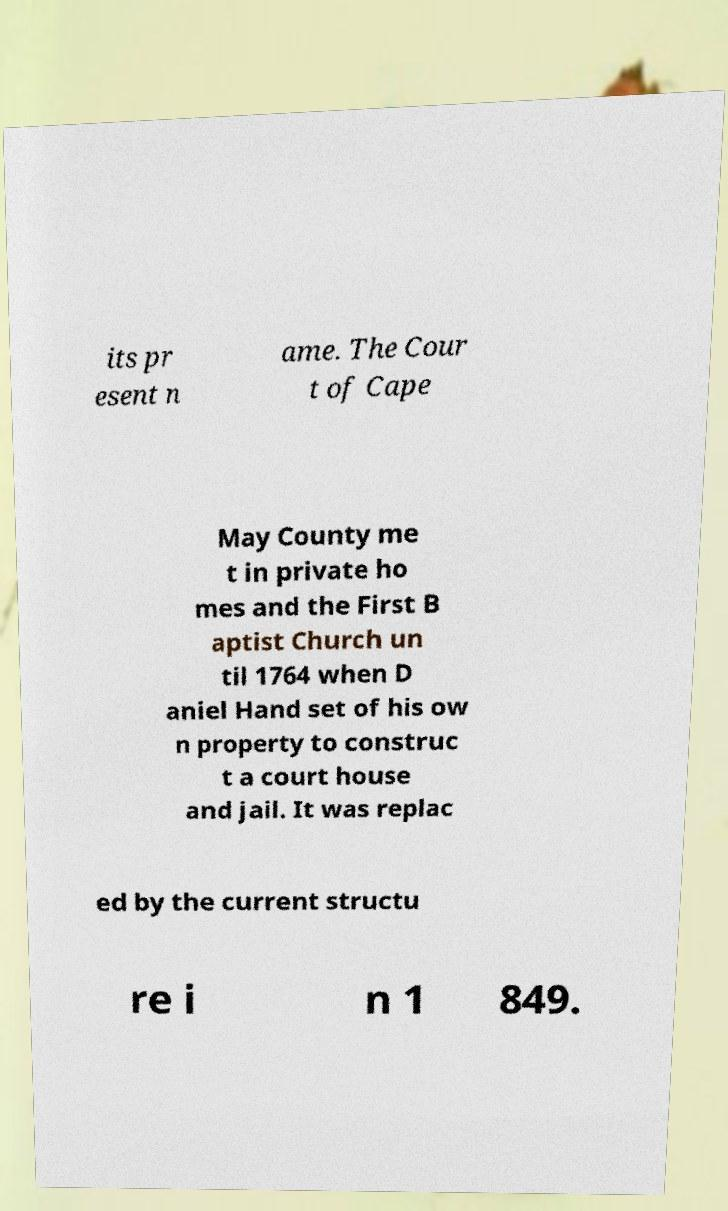For documentation purposes, I need the text within this image transcribed. Could you provide that? its pr esent n ame. The Cour t of Cape May County me t in private ho mes and the First B aptist Church un til 1764 when D aniel Hand set of his ow n property to construc t a court house and jail. It was replac ed by the current structu re i n 1 849. 